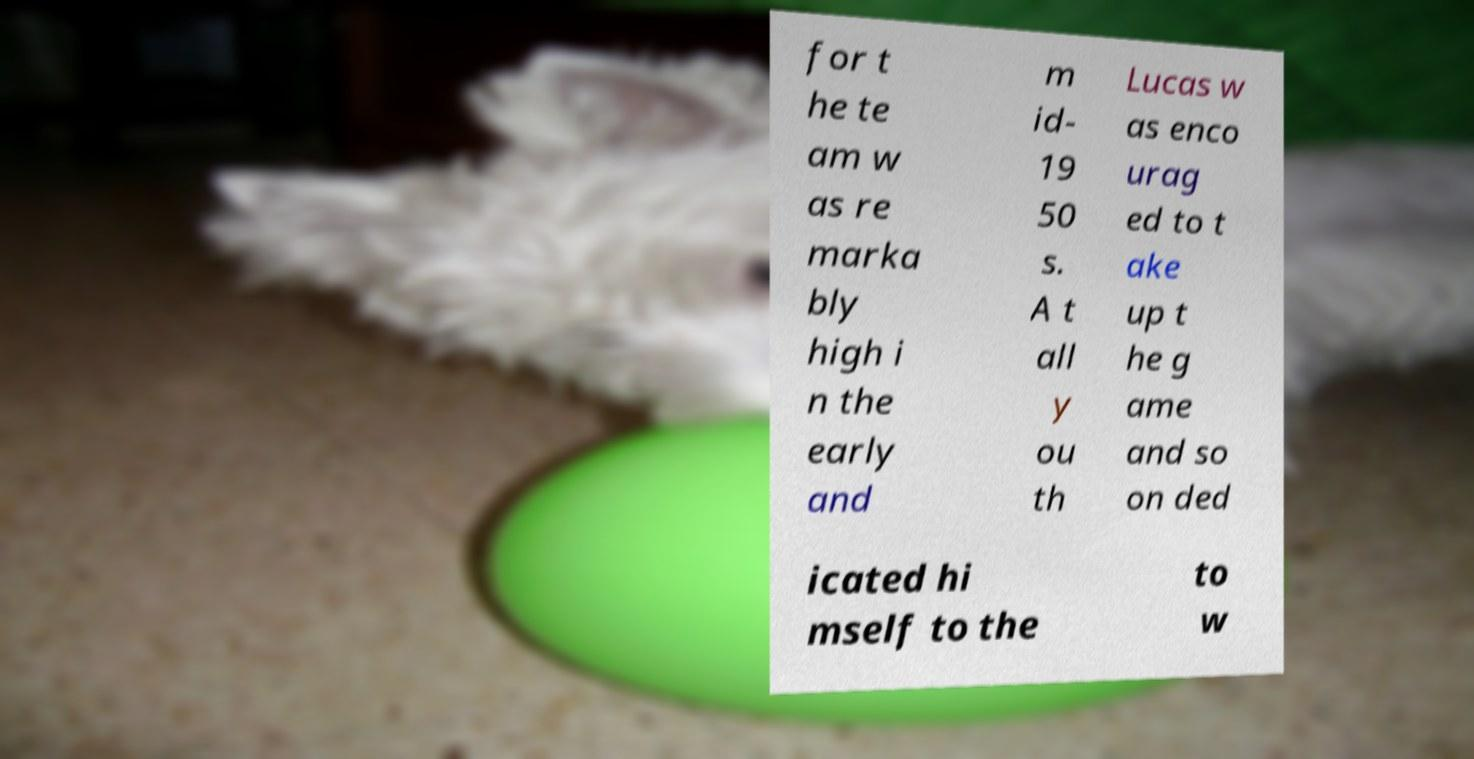Please identify and transcribe the text found in this image. for t he te am w as re marka bly high i n the early and m id- 19 50 s. A t all y ou th Lucas w as enco urag ed to t ake up t he g ame and so on ded icated hi mself to the to w 